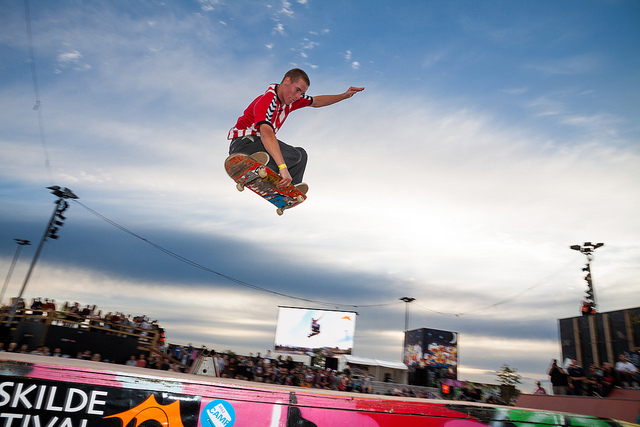What type of skateboard maneuver typically precedes or follows the trick performed by the man in red? The skateboard trick being performed by the man in red, known as a 'grab,' can often be preceded by a ramp launch or an ollie to gain the necessary air. Following the grab, skateboarders may add a rotation before landing, such as a 180 or 360 degree turn, to increase the complexity of the trick. The key is to maintain control and balance for a smooth re-entry to the ramp or landing surface. 